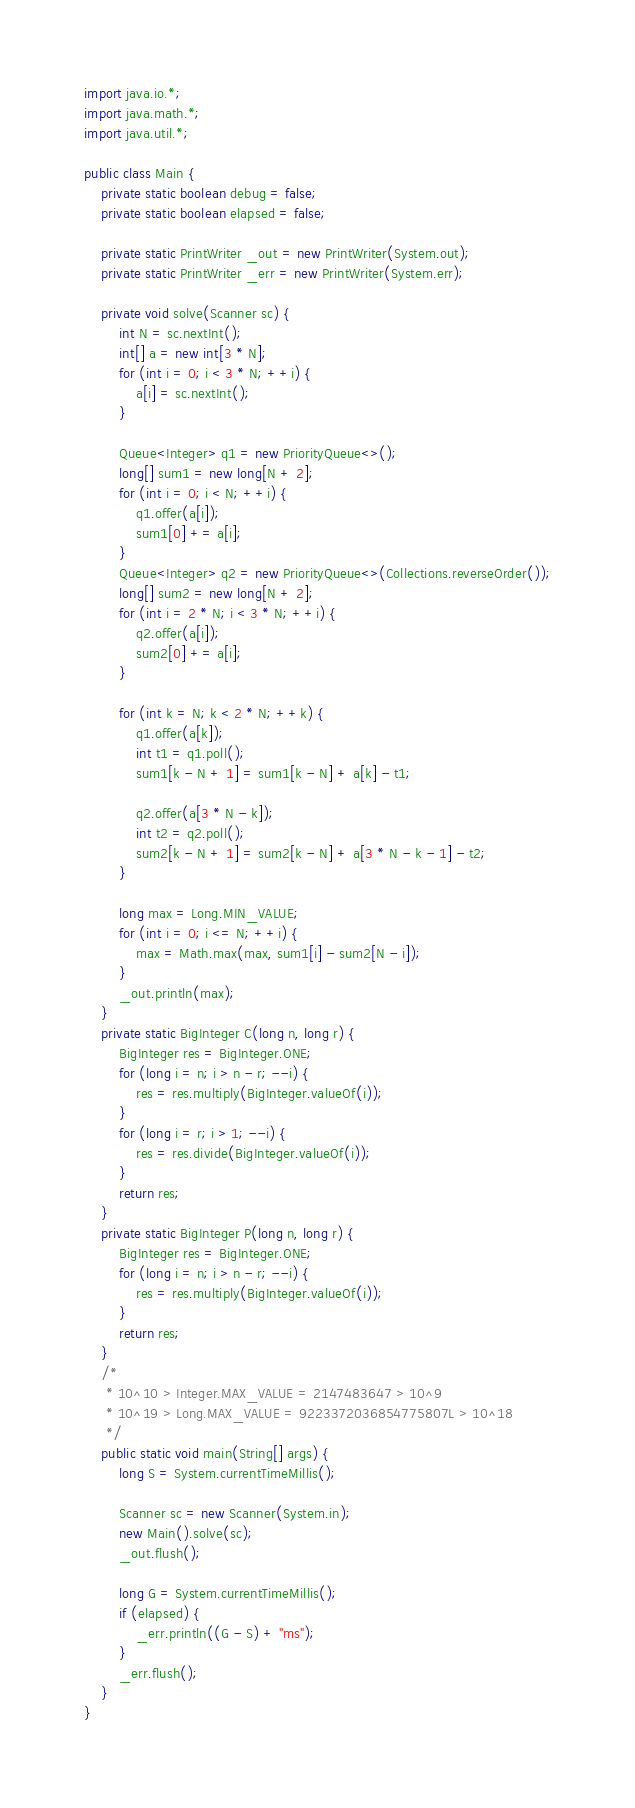Convert code to text. <code><loc_0><loc_0><loc_500><loc_500><_Java_>import java.io.*;
import java.math.*;
import java.util.*;

public class Main {
    private static boolean debug = false;
    private static boolean elapsed = false;

    private static PrintWriter _out = new PrintWriter(System.out);
    private static PrintWriter _err = new PrintWriter(System.err);

    private void solve(Scanner sc) {
        int N = sc.nextInt();
        int[] a = new int[3 * N];
        for (int i = 0; i < 3 * N; ++i) {
            a[i] = sc.nextInt();
        }

        Queue<Integer> q1 = new PriorityQueue<>();
        long[] sum1 = new long[N + 2];
        for (int i = 0; i < N; ++i) {
            q1.offer(a[i]);
            sum1[0] += a[i];
        }
        Queue<Integer> q2 = new PriorityQueue<>(Collections.reverseOrder());
        long[] sum2 = new long[N + 2];
        for (int i = 2 * N; i < 3 * N; ++i) {
            q2.offer(a[i]);
            sum2[0] += a[i];
        }

        for (int k = N; k < 2 * N; ++k) {
            q1.offer(a[k]);
            int t1 = q1.poll();
            sum1[k - N + 1] = sum1[k - N] + a[k] - t1;

            q2.offer(a[3 * N - k]);
            int t2 = q2.poll();
            sum2[k - N + 1] = sum2[k - N] + a[3 * N - k - 1] - t2;
        }

        long max = Long.MIN_VALUE;
        for (int i = 0; i <= N; ++i) {
            max = Math.max(max, sum1[i] - sum2[N - i]);
        }
        _out.println(max);
    }
    private static BigInteger C(long n, long r) {
        BigInteger res = BigInteger.ONE;
        for (long i = n; i > n - r; --i) {
            res = res.multiply(BigInteger.valueOf(i));
        }
        for (long i = r; i > 1; --i) {
            res = res.divide(BigInteger.valueOf(i));
        }
        return res;
    }
    private static BigInteger P(long n, long r) {
        BigInteger res = BigInteger.ONE;
        for (long i = n; i > n - r; --i) {
            res = res.multiply(BigInteger.valueOf(i));
        }
        return res;
    }
    /*
     * 10^10 > Integer.MAX_VALUE = 2147483647 > 10^9
     * 10^19 > Long.MAX_VALUE = 9223372036854775807L > 10^18
     */
    public static void main(String[] args) {
        long S = System.currentTimeMillis();

        Scanner sc = new Scanner(System.in);
        new Main().solve(sc);
        _out.flush();

        long G = System.currentTimeMillis();
        if (elapsed) {
            _err.println((G - S) + "ms");
        }
        _err.flush();
    }
}</code> 